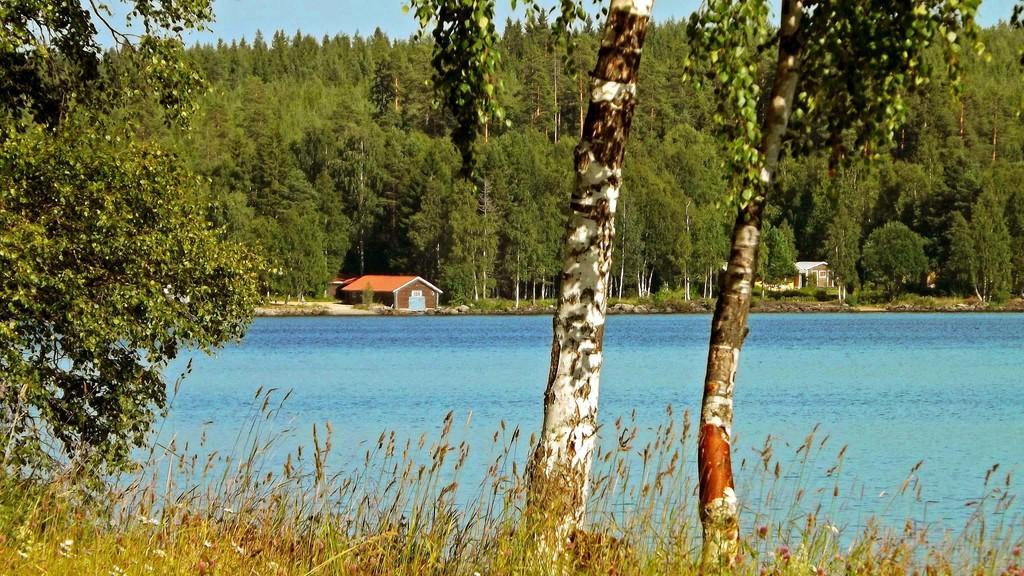In one or two sentences, can you explain what this image depicts? In the foreground of this picture, there are trees and the grass at front. In the background, there is water, houses, trees and the sky. 